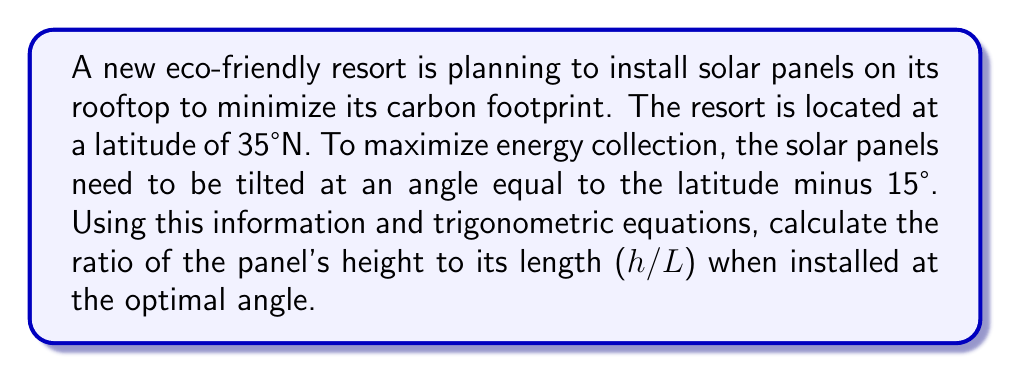Can you answer this question? Let's approach this step-by-step:

1) First, we need to determine the optimal angle for the solar panels:
   Optimal angle = Latitude - 15°
   $$ \theta = 35° - 15° = 20° $$

2) Now, we can visualize the solar panel as a right triangle:
   [asy]
   import geometry;
   size(200);
   pair A=(0,0), B=(5,0), C=(5,1.82);
   draw(A--B--C--A);
   draw(B--(5,-0.5),arrow=Arrow(TeXHead));
   draw((5.2,0)--(5.2,1.82),arrow=Arrow(TeXHead));
   label("L",(-0.2,2.5),E);
   label("h",(5.3,0.91),E);
   label("20°",(0.5,0.2),NE);
   [/asy]

3) In this triangle, we're looking for the ratio of h (height) to L (length).
   This ratio is equal to the sine of the angle:

   $$ \frac{h}{L} = \sin(\theta) $$

4) Substituting our optimal angle:

   $$ \frac{h}{L} = \sin(20°) $$

5) Using a calculator or trigonometric tables:

   $$ \frac{h}{L} = 0.3420 $$

Thus, the ratio of the panel's height to its length when installed at the optimal angle is approximately 0.3420.
Answer: $\frac{h}{L} = 0.3420$ 